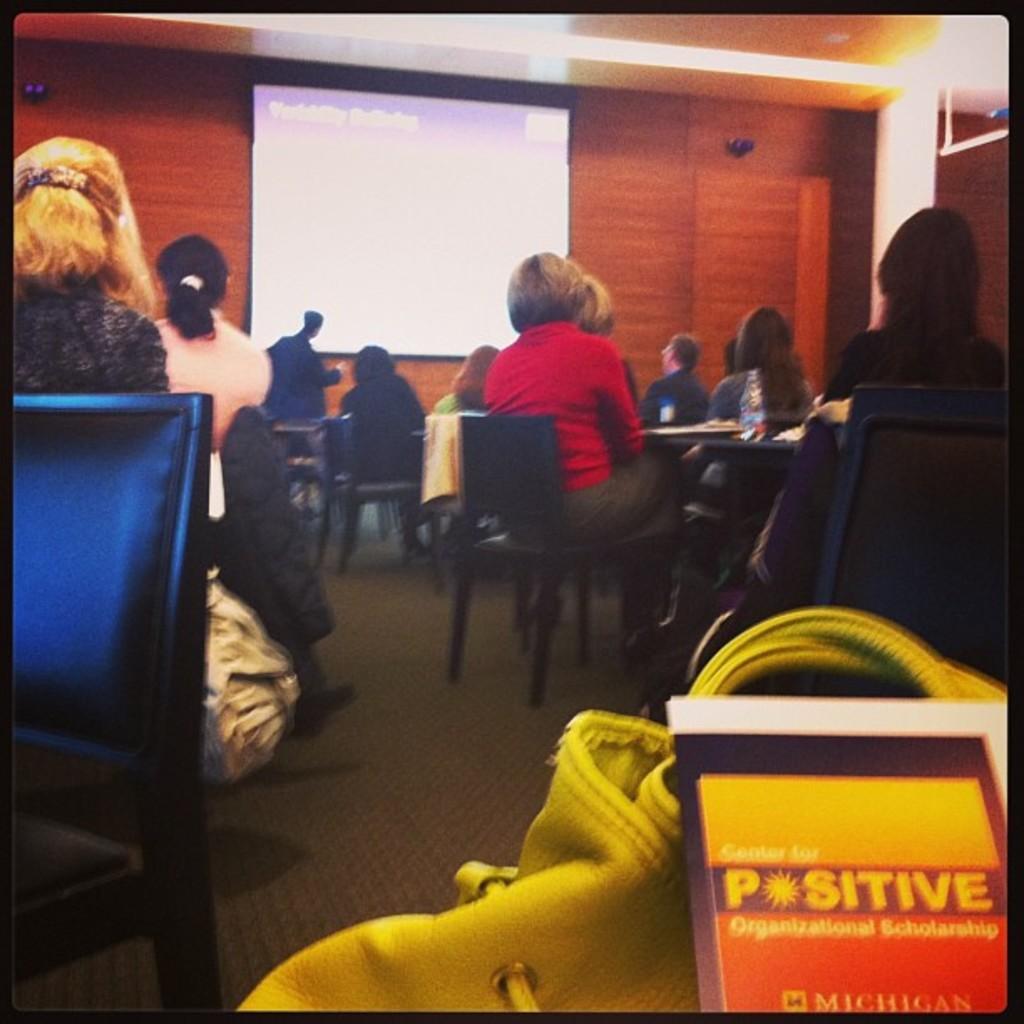Could you give a brief overview of what you see in this image? In this image I can see a group of people sitting in chairs facing towards the back. I can see a screen and a person standing before the screen. I can see a wall behind the screen. In the bottom right corner I can see a leather bag and a book with some text.  